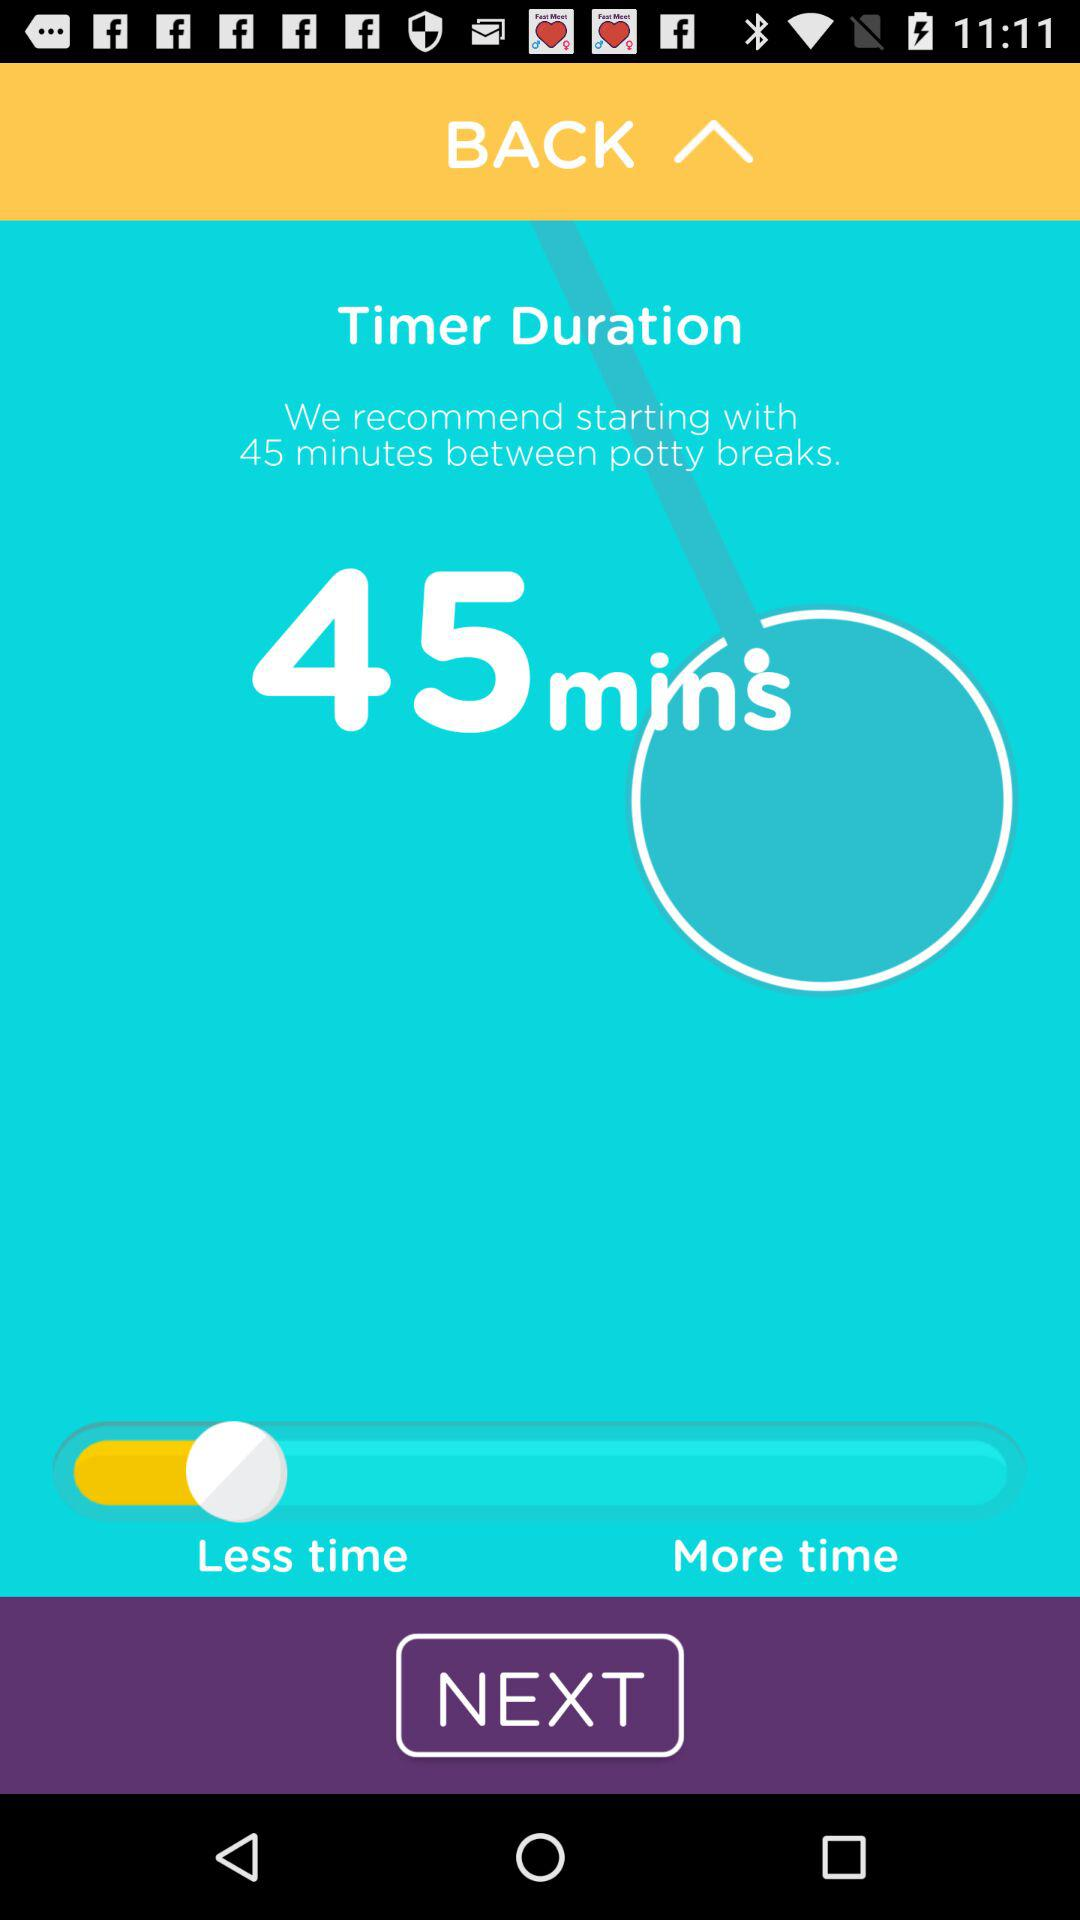What is the name of the application?
When the provided information is insufficient, respond with <no answer>. <no answer> 